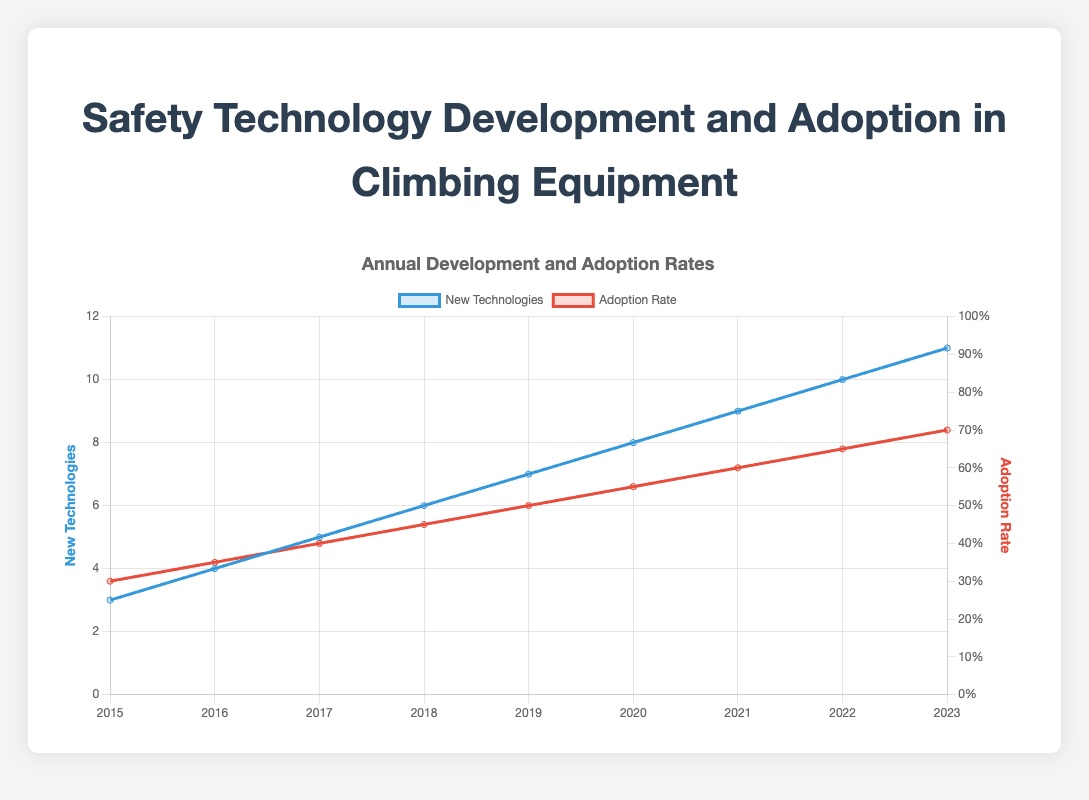What's the difference in the number of new technologies developed between 2015 and 2023? In 2015, 3 new technologies were developed, and in 2023, 11 new technologies were developed. The difference is 11 - 3 = 8.
Answer: 8 What was the adoption rate in 2018? The adoption rate in 2018 can be directly read off the chart for the year 2018. It is 0.45.
Answer: 0.45 Which year had the highest adoption rate? Reviewing the adoption rates from 2015 to 2023 on the chart, the highest adoption rate is in the year 2023, which is 0.70.
Answer: 2023 Compare the adoption rates between 2016 and 2020. Which year had a higher rate? The adoption rates in 2016 and 2020 are 0.35 and 0.55 respectively. 0.55 (2020) is greater than 0.35 (2016). So, the year 2020 had a higher adoption rate.
Answer: 2020 Calculate the average adoption rate over the entire period from 2015 to 2023. The sum of the adoption rates from 2015 to 2023 is 0.30 + 0.35 + 0.40 + 0.45 + 0.50 + 0.55 + 0.60 + 0.65 + 0.70 = 4.50. There are 9 data points, so the average adoption rate is 4.50 / 9 = 0.50.
Answer: 0.50 What is the adoption rate as a percentage in 2021? The adoption rate for 2021 is 0.60. As a percentage, this is 0.60 * 100 = 60%.
Answer: 60% By how much did the number of new technologies increase from 2017 to 2019? The number of new technologies in 2017 was 5, and in 2019 it was 7. The increase is 7 - 5 = 2.
Answer: 2 Is there a year where both the number of new technologies and the adoption rate were exactly the midpoints of their respective ranges? The range for new technologies is from 3 to 11 (2015 to 2023), making the midpoint 7. The range for adoption rate is from 0.30 to 0.70, making the midpoint 0.50. In the year 2019, new technologies = 7 and adoption rate = 0.50, both are midpoints.
Answer: 2019 Which color represents the adoption rate in the plot? The adoption rate is represented by the red line in the plot.
Answer: Red 